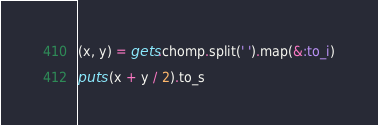<code> <loc_0><loc_0><loc_500><loc_500><_Ruby_>(x, y) = gets.chomp.split(' ').map(&:to_i)

puts (x + y / 2).to_s</code> 